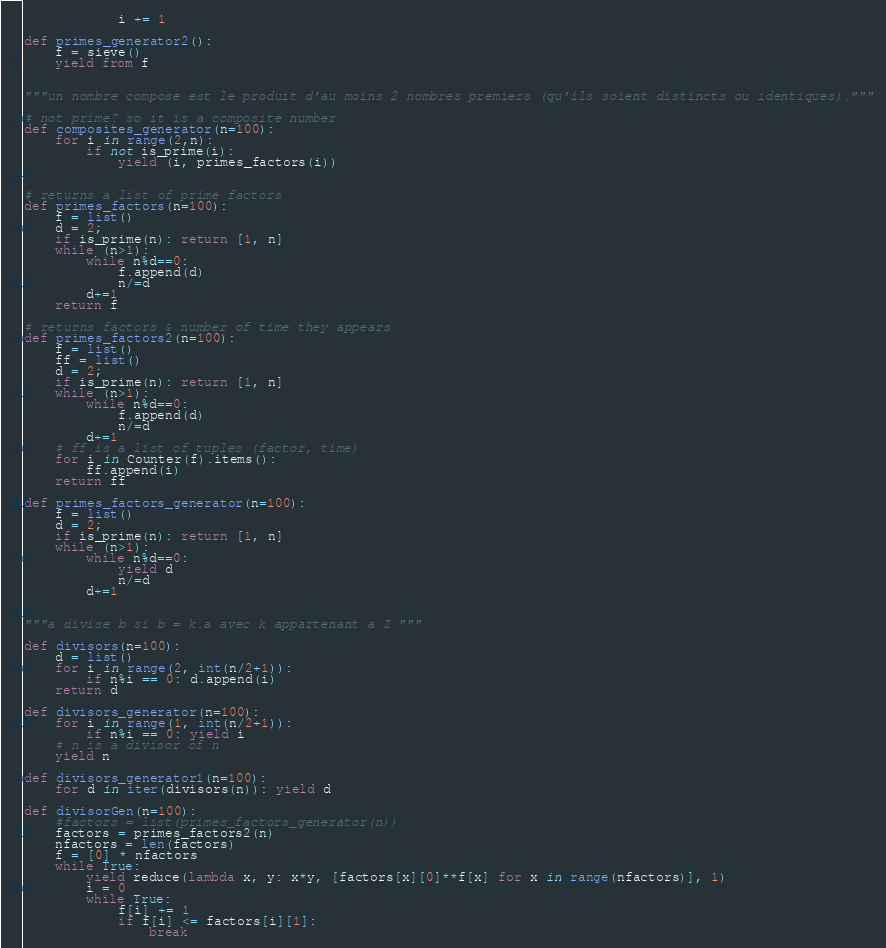Convert code to text. <code><loc_0><loc_0><loc_500><loc_500><_Python_>            i += 1

def primes_generator2():
    f = sieve()
    yield from f


"""un nombre composé est le produit d'au moins 2 nombres premiers (qu'ils soient distincts ou identiques)."""

# not prime? so it is a composite number
def composites_generator(n=100):
    for i in range(2,n):
        if not is_prime(i):
            yield (i, primes_factors(i))


# returns a list of prime factors
def primes_factors(n=100):
    f = list()
    d = 2;
    if is_prime(n): return [1, n]
    while (n>1):
        while n%d==0:
            f.append(d)
            n/=d
        d+=1
    return f

# returns factors & number of time they appears
def primes_factors2(n=100):
    f = list()
    ff = list()
    d = 2;
    if is_prime(n): return [1, n]
    while (n>1):
        while n%d==0:
            f.append(d)
            n/=d
        d+=1
    # ff is a list of tuples (factor, time)
    for i in Counter(f).items():
        ff.append(i)
    return ff

def primes_factors_generator(n=100):
    f = list()
    d = 2;
    if is_prime(n): return [1, n]
    while (n>1):
        while n%d==0:
            yield d
            n/=d
        d+=1


"""a divise b si b = k.a avec k appartenant a Z """

def divisors(n=100):
    d = list()
    for i in range(2, int(n/2+1)):
        if n%i == 0: d.append(i)
    return d

def divisors_generator(n=100):
    for i in range(1, int(n/2+1)):
        if n%i == 0: yield i
    # n is a divisor of n
    yield n

def divisors_generator1(n=100):
    for d in iter(divisors(n)): yield d

def divisorGen(n=100):
    #factors = list(primes_factors_generator(n))
    factors = primes_factors2(n)
    nfactors = len(factors)
    f = [0] * nfactors
    while True:
        yield reduce(lambda x, y: x*y, [factors[x][0]**f[x] for x in range(nfactors)], 1)
        i = 0
        while True:
            f[i] += 1
            if f[i] <= factors[i][1]:
                break</code> 